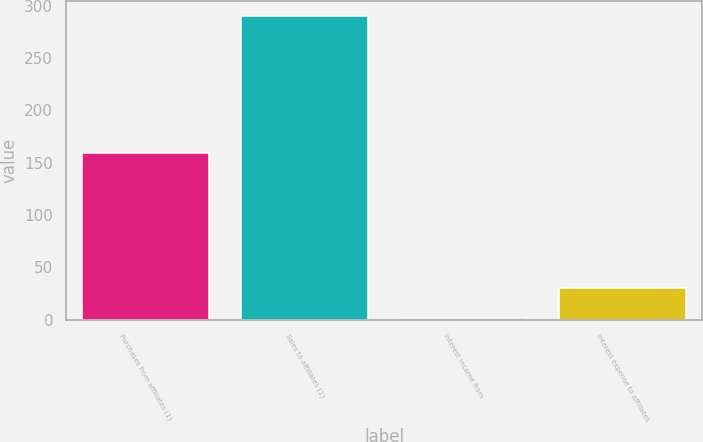Convert chart to OTSL. <chart><loc_0><loc_0><loc_500><loc_500><bar_chart><fcel>Purchases from affiliates (1)<fcel>Sales to affiliates (1)<fcel>Interest income from<fcel>Interest expense to affiliates<nl><fcel>159<fcel>290<fcel>1<fcel>29.9<nl></chart> 